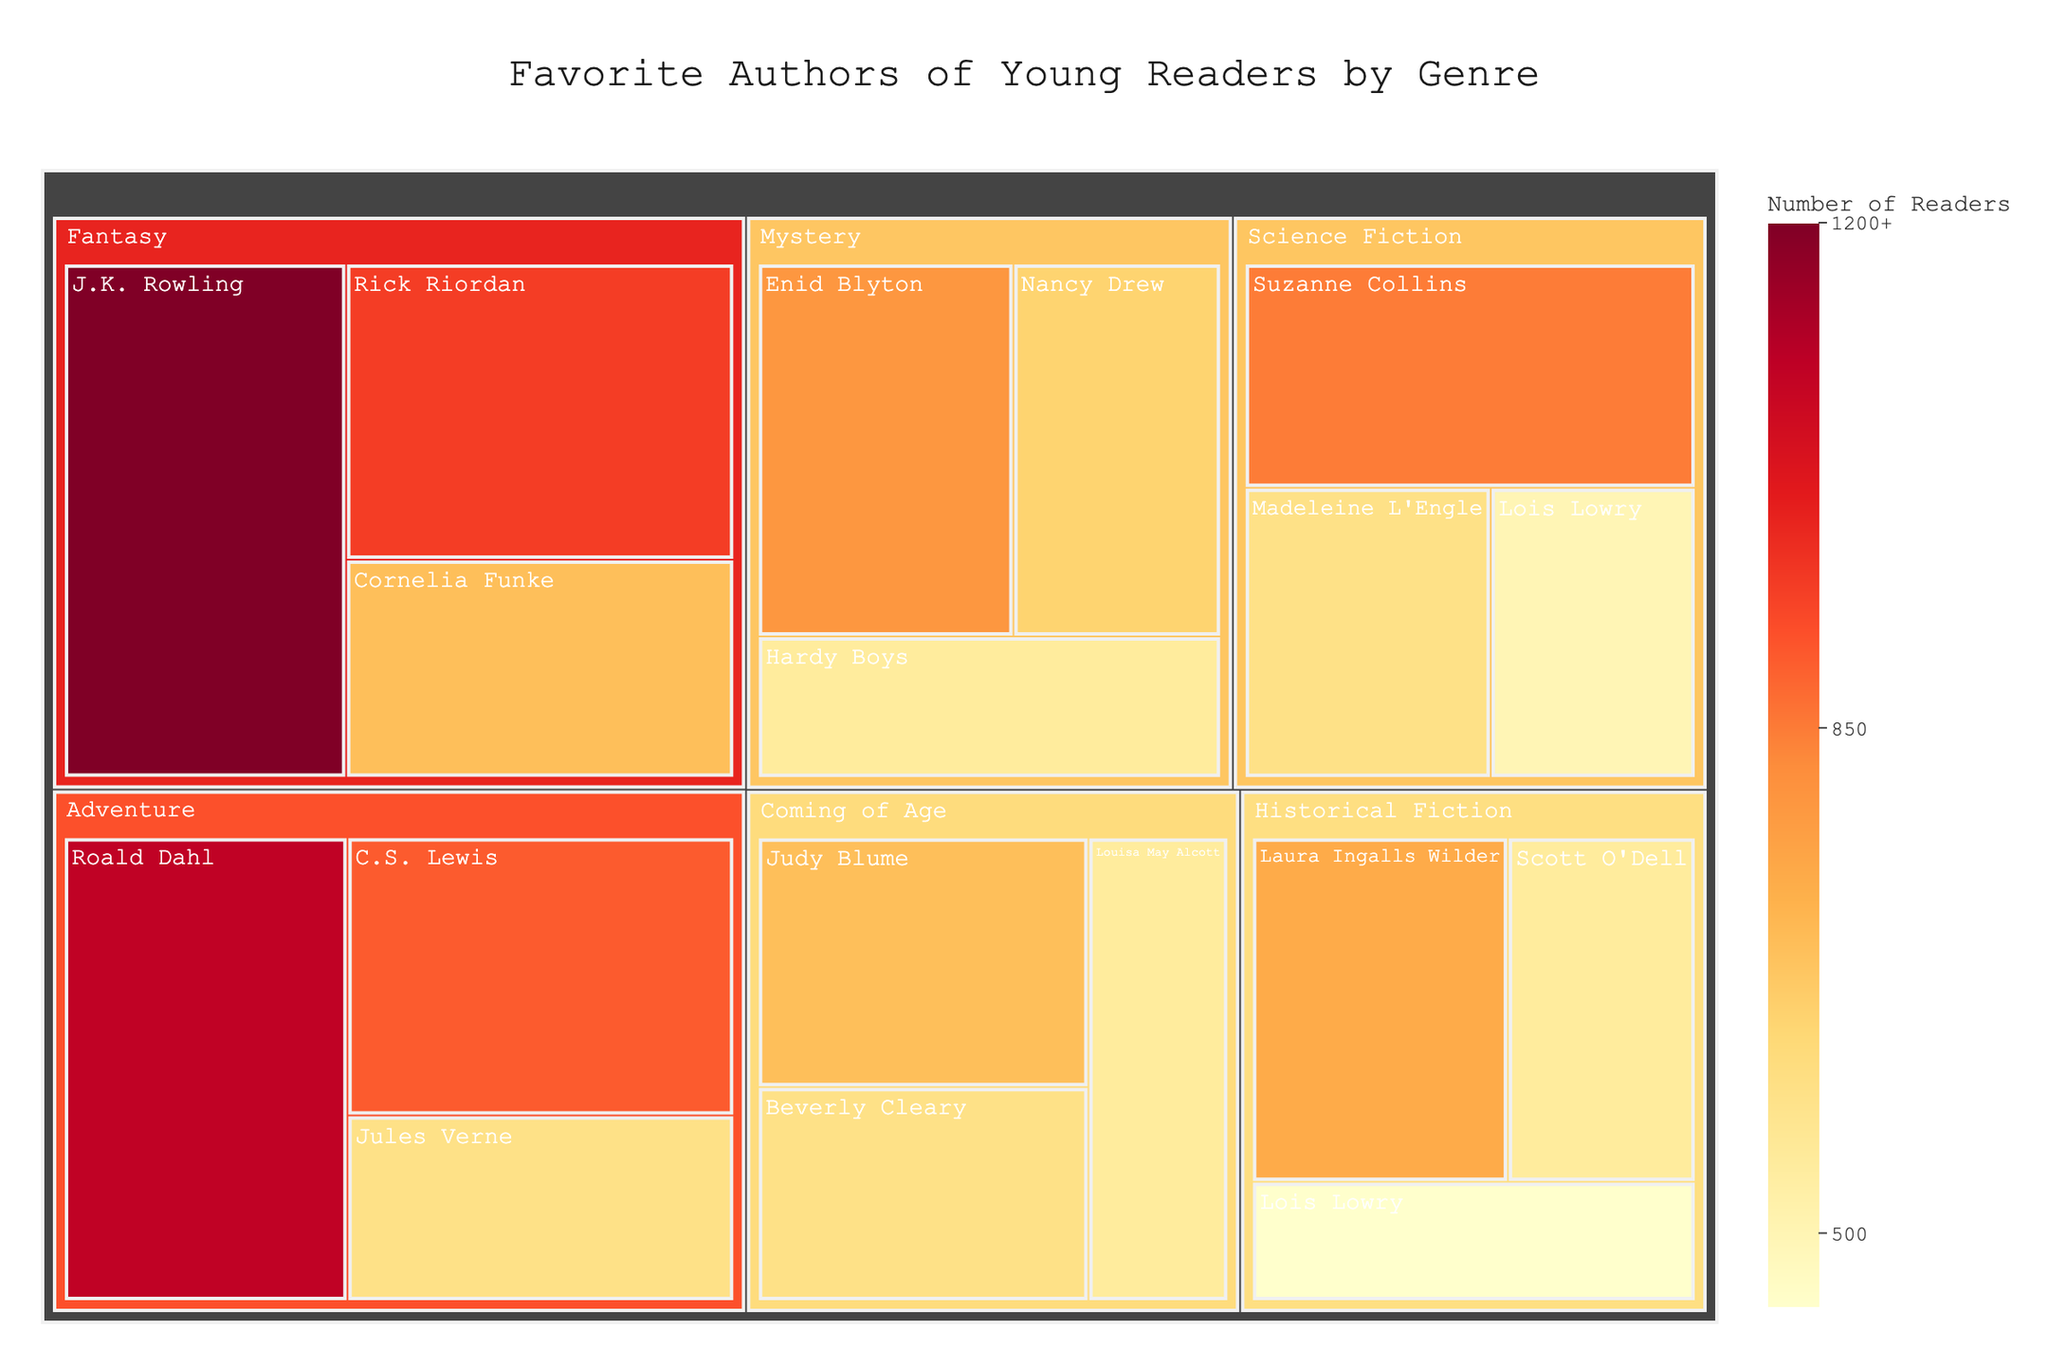What's the title of the treemap? The title is usually prominently displayed at the top of the figure, and it's meant to give a quick understanding of what the visualization represents.
Answer: Favorite Authors of Young Readers by Genre Which author in the Fantasy genre has the most readers? To determine this, look within the subsection labeled "Fantasy" and identify the author with the largest section/box.
Answer: J.K. Rowling How many readers are there for Suzanne Collins? Locate Suzanne Collins within the Science Fiction genre and refer to the value indicated in her section.
Answer: 850 What is the total number of readers for the Mystery genre? Sum up the readers of all authors within the Mystery genre: Enid Blyton (800), Nancy Drew (650), and Hardy Boys (550). Therefore, the total number is 800 + 650 + 550.
Answer: 2000 Between Cornelia Funke and Jules Verne, who has more readers, and by how many? Compare the number of readers for Cornelia Funke (700, Fantasy) and Jules Verne (600, Adventure). Subtract 600 from 700 to find the difference.
Answer: Cornelia Funke by 100 Which genre has the least number of readers represented for any single author, and who is that author? Identify the genre with the smallest maximum number of readers for any of its authors. Compare the readers’ figures across all authors and genres.
Answer: Coming of Age, Louisa May Alcott (550) What's the total number of readers for the authors in the Adventure genre? Sum up the readers of all authors in the Adventure genre: Roald Dahl (1100), C.S. Lewis (900), and Jules Verne (600).
Answer: 2600 In the Science Fiction genre, who has more readers, Madeleine L'Engle or Lois Lowry? Compare the numbers for Madeleine L'Engle (600) and Lois Lowry (500) within the Science Fiction genre.
Answer: Madeleine L'Engle How many total readers are represented in the Coming of Age genre? Add the readers for all the authors in the Coming of Age genre: Judy Blume (700), Beverly Cleary (600), and Louisa May Alcott (550).
Answer: 1850 